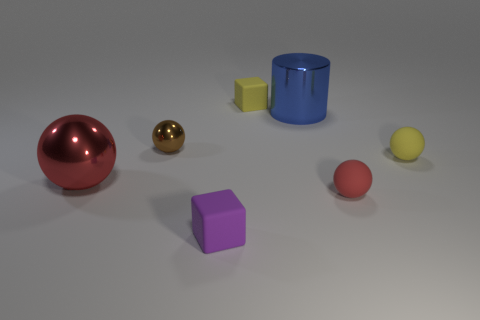Do the red matte ball and the red ball to the left of the brown metallic thing have the same size?
Provide a short and direct response. No. Are there any big spheres that have the same color as the tiny shiny thing?
Your answer should be compact. No. How many small objects are red spheres or metal balls?
Your answer should be very brief. 2. How many rubber balls are there?
Your answer should be very brief. 2. What is the red object that is right of the cylinder made of?
Give a very brief answer. Rubber. Are there any yellow matte cubes on the right side of the tiny yellow cube?
Make the answer very short. No. Is the yellow rubber ball the same size as the purple matte block?
Offer a terse response. Yes. How many things are made of the same material as the small brown sphere?
Offer a very short reply. 2. What size is the red ball in front of the red metallic thing that is in front of the big blue cylinder?
Your answer should be very brief. Small. There is a rubber thing that is both left of the tiny red rubber ball and behind the red metal object; what is its color?
Provide a succinct answer. Yellow. 